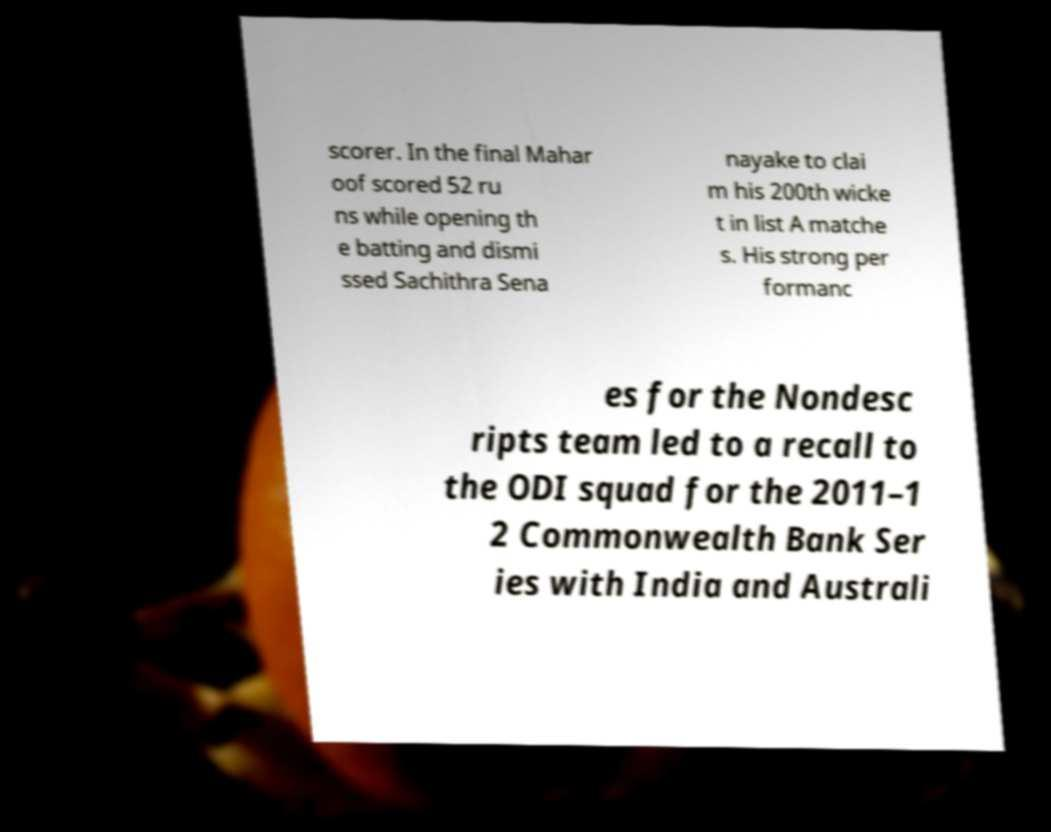Could you extract and type out the text from this image? scorer. In the final Mahar oof scored 52 ru ns while opening th e batting and dismi ssed Sachithra Sena nayake to clai m his 200th wicke t in list A matche s. His strong per formanc es for the Nondesc ripts team led to a recall to the ODI squad for the 2011–1 2 Commonwealth Bank Ser ies with India and Australi 